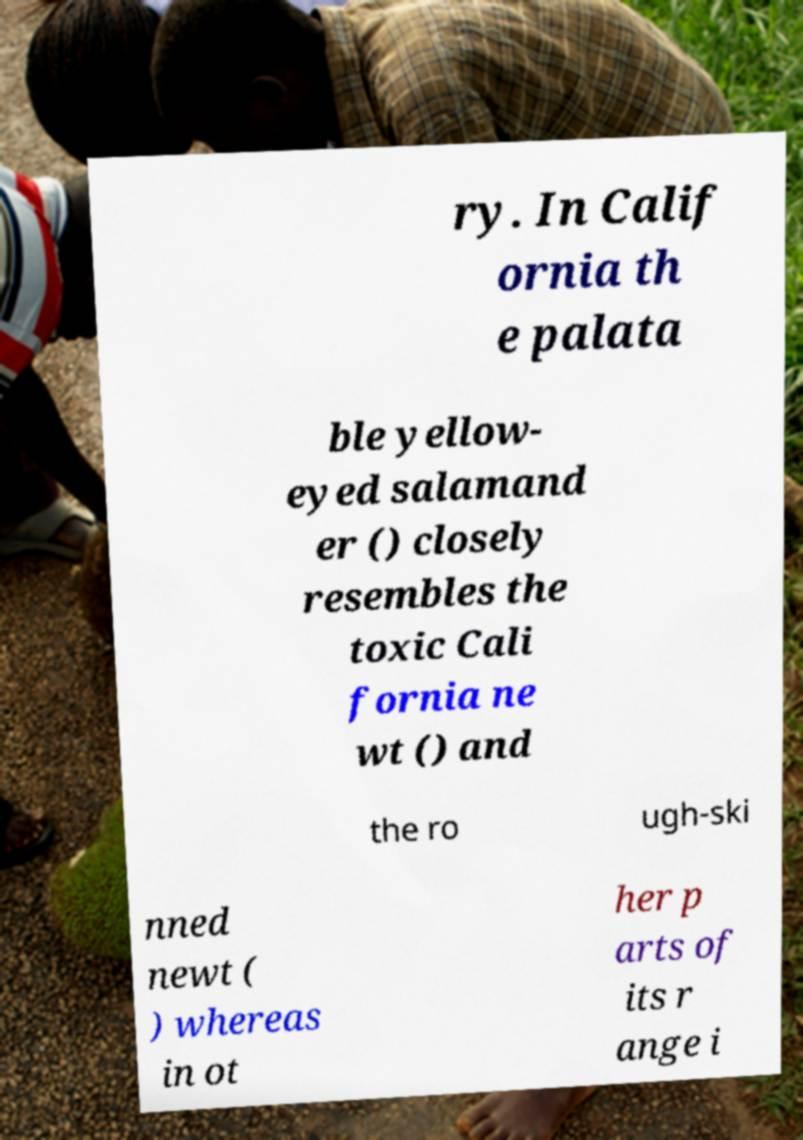I need the written content from this picture converted into text. Can you do that? ry. In Calif ornia th e palata ble yellow- eyed salamand er () closely resembles the toxic Cali fornia ne wt () and the ro ugh-ski nned newt ( ) whereas in ot her p arts of its r ange i 